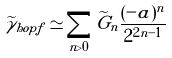<formula> <loc_0><loc_0><loc_500><loc_500>\widetilde { \gamma } _ { h o p f } \simeq \sum _ { n > 0 } \widetilde { G } _ { n } { \frac { ( - a ) ^ { n } } { 2 ^ { 2 n - 1 } } }</formula> 